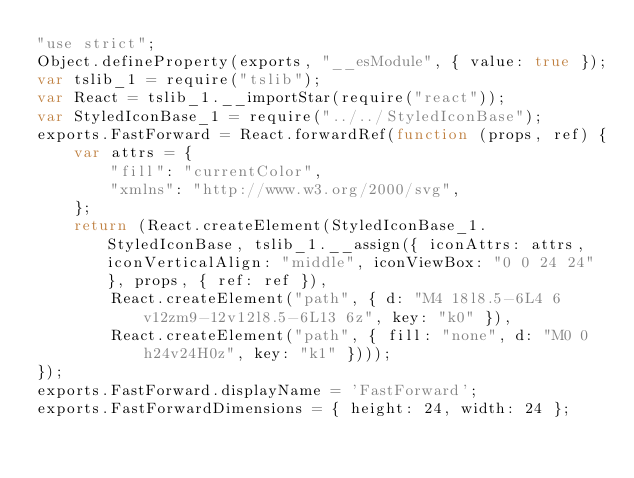Convert code to text. <code><loc_0><loc_0><loc_500><loc_500><_JavaScript_>"use strict";
Object.defineProperty(exports, "__esModule", { value: true });
var tslib_1 = require("tslib");
var React = tslib_1.__importStar(require("react"));
var StyledIconBase_1 = require("../../StyledIconBase");
exports.FastForward = React.forwardRef(function (props, ref) {
    var attrs = {
        "fill": "currentColor",
        "xmlns": "http://www.w3.org/2000/svg",
    };
    return (React.createElement(StyledIconBase_1.StyledIconBase, tslib_1.__assign({ iconAttrs: attrs, iconVerticalAlign: "middle", iconViewBox: "0 0 24 24" }, props, { ref: ref }),
        React.createElement("path", { d: "M4 18l8.5-6L4 6v12zm9-12v12l8.5-6L13 6z", key: "k0" }),
        React.createElement("path", { fill: "none", d: "M0 0h24v24H0z", key: "k1" })));
});
exports.FastForward.displayName = 'FastForward';
exports.FastForwardDimensions = { height: 24, width: 24 };
</code> 